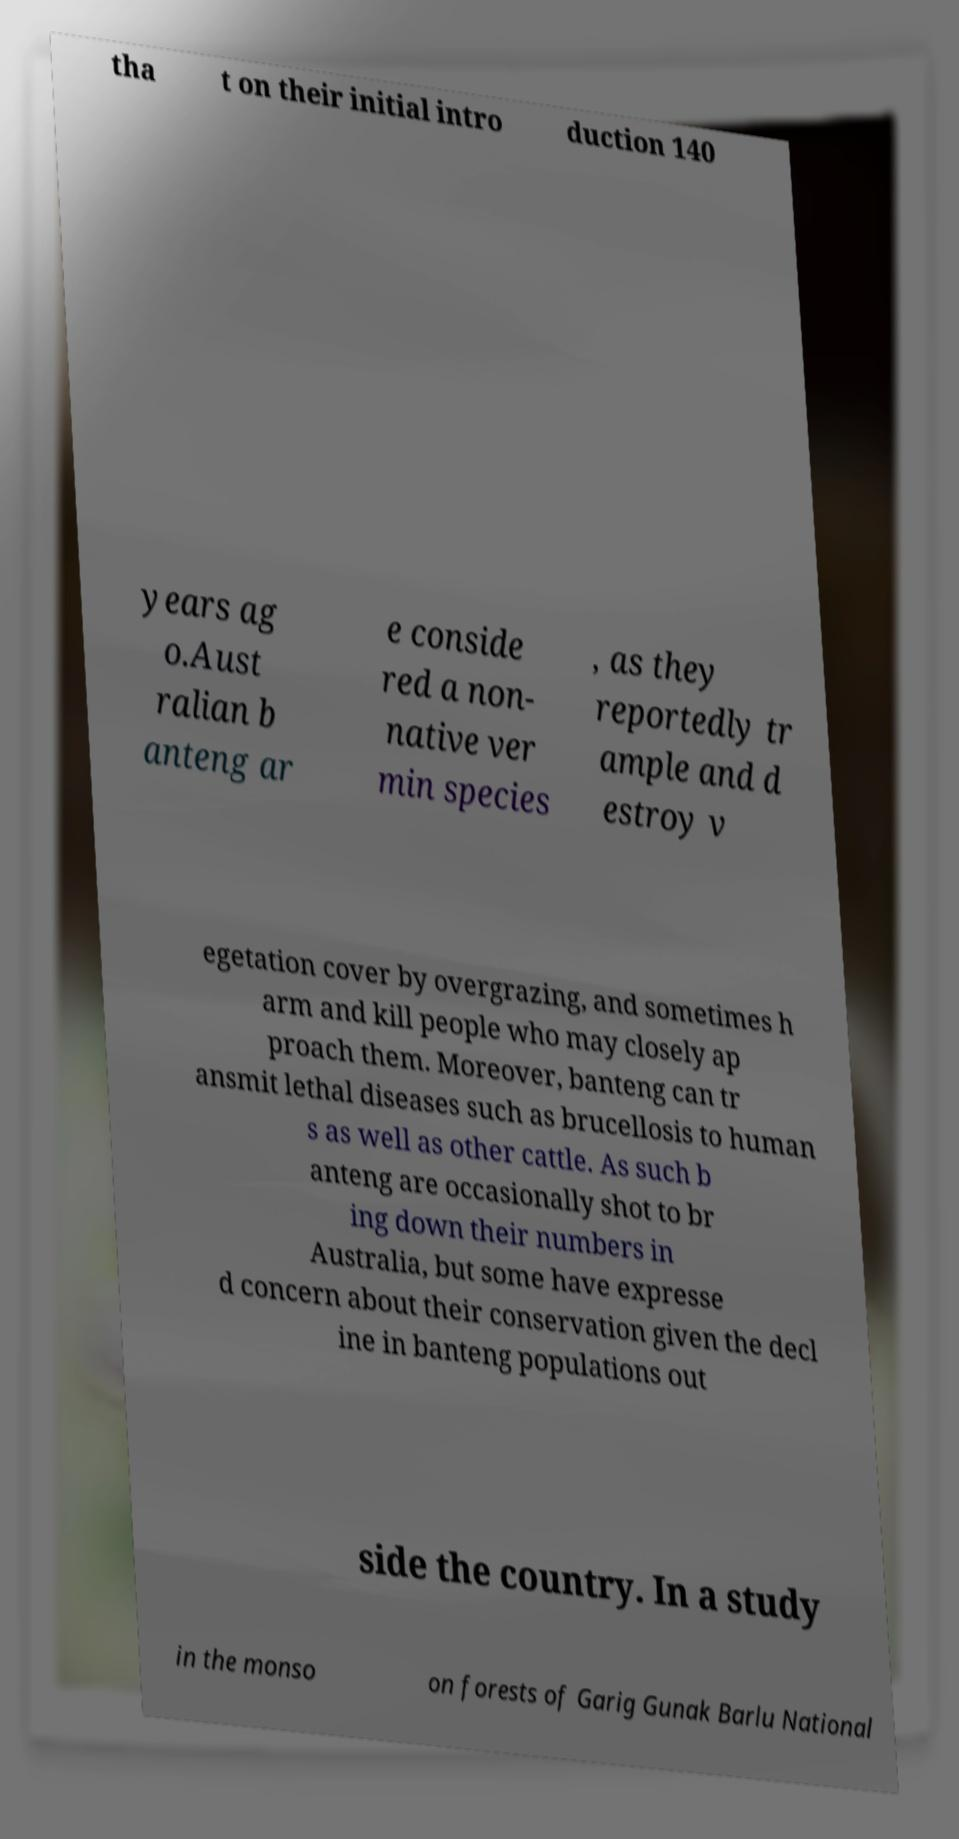For documentation purposes, I need the text within this image transcribed. Could you provide that? tha t on their initial intro duction 140 years ag o.Aust ralian b anteng ar e conside red a non- native ver min species , as they reportedly tr ample and d estroy v egetation cover by overgrazing, and sometimes h arm and kill people who may closely ap proach them. Moreover, banteng can tr ansmit lethal diseases such as brucellosis to human s as well as other cattle. As such b anteng are occasionally shot to br ing down their numbers in Australia, but some have expresse d concern about their conservation given the decl ine in banteng populations out side the country. In a study in the monso on forests of Garig Gunak Barlu National 